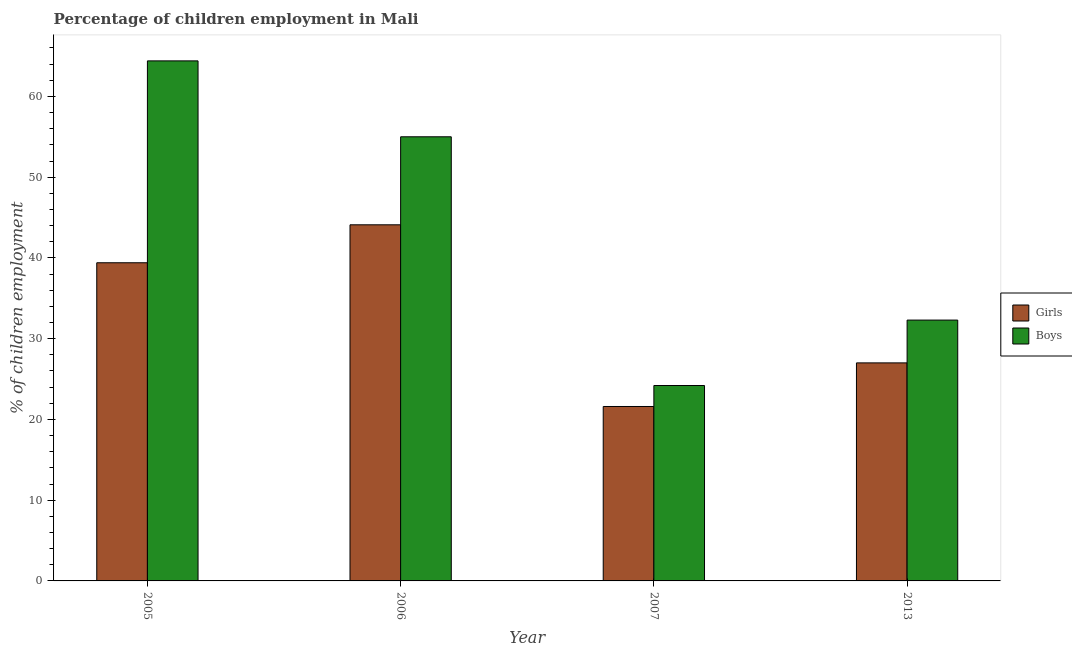How many groups of bars are there?
Provide a succinct answer. 4. Are the number of bars on each tick of the X-axis equal?
Keep it short and to the point. Yes. How many bars are there on the 4th tick from the left?
Provide a short and direct response. 2. What is the label of the 4th group of bars from the left?
Your response must be concise. 2013. In how many cases, is the number of bars for a given year not equal to the number of legend labels?
Ensure brevity in your answer.  0. What is the percentage of employed boys in 2005?
Offer a very short reply. 64.4. Across all years, what is the maximum percentage of employed boys?
Offer a very short reply. 64.4. Across all years, what is the minimum percentage of employed boys?
Give a very brief answer. 24.2. In which year was the percentage of employed boys maximum?
Offer a very short reply. 2005. In which year was the percentage of employed boys minimum?
Give a very brief answer. 2007. What is the total percentage of employed girls in the graph?
Offer a very short reply. 132.1. What is the difference between the percentage of employed boys in 2005 and that in 2006?
Provide a short and direct response. 9.4. What is the difference between the percentage of employed boys in 2013 and the percentage of employed girls in 2006?
Provide a short and direct response. -22.7. What is the average percentage of employed girls per year?
Keep it short and to the point. 33.02. In the year 2013, what is the difference between the percentage of employed girls and percentage of employed boys?
Provide a succinct answer. 0. What is the ratio of the percentage of employed boys in 2005 to that in 2006?
Offer a very short reply. 1.17. Is the percentage of employed girls in 2006 less than that in 2013?
Ensure brevity in your answer.  No. Is the difference between the percentage of employed girls in 2005 and 2013 greater than the difference between the percentage of employed boys in 2005 and 2013?
Your response must be concise. No. What is the difference between the highest and the second highest percentage of employed boys?
Your answer should be very brief. 9.4. What is the difference between the highest and the lowest percentage of employed boys?
Offer a terse response. 40.2. What does the 1st bar from the left in 2006 represents?
Your response must be concise. Girls. What does the 2nd bar from the right in 2006 represents?
Offer a very short reply. Girls. How many bars are there?
Offer a terse response. 8. Are the values on the major ticks of Y-axis written in scientific E-notation?
Ensure brevity in your answer.  No. Does the graph contain grids?
Make the answer very short. No. Where does the legend appear in the graph?
Your response must be concise. Center right. How many legend labels are there?
Offer a terse response. 2. What is the title of the graph?
Offer a very short reply. Percentage of children employment in Mali. What is the label or title of the X-axis?
Your answer should be very brief. Year. What is the label or title of the Y-axis?
Give a very brief answer. % of children employment. What is the % of children employment in Girls in 2005?
Your response must be concise. 39.4. What is the % of children employment in Boys in 2005?
Offer a very short reply. 64.4. What is the % of children employment in Girls in 2006?
Keep it short and to the point. 44.1. What is the % of children employment in Girls in 2007?
Your response must be concise. 21.6. What is the % of children employment in Boys in 2007?
Ensure brevity in your answer.  24.2. What is the % of children employment of Girls in 2013?
Provide a succinct answer. 27. What is the % of children employment in Boys in 2013?
Your answer should be compact. 32.3. Across all years, what is the maximum % of children employment of Girls?
Make the answer very short. 44.1. Across all years, what is the maximum % of children employment of Boys?
Your answer should be very brief. 64.4. Across all years, what is the minimum % of children employment in Girls?
Provide a short and direct response. 21.6. Across all years, what is the minimum % of children employment in Boys?
Give a very brief answer. 24.2. What is the total % of children employment of Girls in the graph?
Ensure brevity in your answer.  132.1. What is the total % of children employment in Boys in the graph?
Your response must be concise. 175.9. What is the difference between the % of children employment in Boys in 2005 and that in 2006?
Provide a succinct answer. 9.4. What is the difference between the % of children employment in Girls in 2005 and that in 2007?
Keep it short and to the point. 17.8. What is the difference between the % of children employment in Boys in 2005 and that in 2007?
Ensure brevity in your answer.  40.2. What is the difference between the % of children employment of Girls in 2005 and that in 2013?
Offer a very short reply. 12.4. What is the difference between the % of children employment in Boys in 2005 and that in 2013?
Your answer should be compact. 32.1. What is the difference between the % of children employment in Girls in 2006 and that in 2007?
Your answer should be very brief. 22.5. What is the difference between the % of children employment in Boys in 2006 and that in 2007?
Provide a short and direct response. 30.8. What is the difference between the % of children employment in Boys in 2006 and that in 2013?
Your response must be concise. 22.7. What is the difference between the % of children employment in Girls in 2007 and that in 2013?
Make the answer very short. -5.4. What is the difference between the % of children employment in Boys in 2007 and that in 2013?
Your answer should be compact. -8.1. What is the difference between the % of children employment of Girls in 2005 and the % of children employment of Boys in 2006?
Provide a succinct answer. -15.6. What is the difference between the % of children employment of Girls in 2005 and the % of children employment of Boys in 2007?
Keep it short and to the point. 15.2. What is the difference between the % of children employment in Girls in 2005 and the % of children employment in Boys in 2013?
Your answer should be compact. 7.1. What is the difference between the % of children employment in Girls in 2006 and the % of children employment in Boys in 2013?
Your answer should be compact. 11.8. What is the difference between the % of children employment of Girls in 2007 and the % of children employment of Boys in 2013?
Provide a short and direct response. -10.7. What is the average % of children employment in Girls per year?
Make the answer very short. 33.02. What is the average % of children employment of Boys per year?
Your answer should be very brief. 43.98. In the year 2005, what is the difference between the % of children employment of Girls and % of children employment of Boys?
Your answer should be compact. -25. What is the ratio of the % of children employment of Girls in 2005 to that in 2006?
Offer a terse response. 0.89. What is the ratio of the % of children employment in Boys in 2005 to that in 2006?
Give a very brief answer. 1.17. What is the ratio of the % of children employment in Girls in 2005 to that in 2007?
Ensure brevity in your answer.  1.82. What is the ratio of the % of children employment in Boys in 2005 to that in 2007?
Provide a succinct answer. 2.66. What is the ratio of the % of children employment in Girls in 2005 to that in 2013?
Your answer should be compact. 1.46. What is the ratio of the % of children employment in Boys in 2005 to that in 2013?
Make the answer very short. 1.99. What is the ratio of the % of children employment of Girls in 2006 to that in 2007?
Make the answer very short. 2.04. What is the ratio of the % of children employment of Boys in 2006 to that in 2007?
Ensure brevity in your answer.  2.27. What is the ratio of the % of children employment in Girls in 2006 to that in 2013?
Provide a succinct answer. 1.63. What is the ratio of the % of children employment in Boys in 2006 to that in 2013?
Your response must be concise. 1.7. What is the ratio of the % of children employment in Girls in 2007 to that in 2013?
Provide a succinct answer. 0.8. What is the ratio of the % of children employment in Boys in 2007 to that in 2013?
Make the answer very short. 0.75. What is the difference between the highest and the lowest % of children employment in Boys?
Make the answer very short. 40.2. 